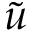Convert formula to latex. <formula><loc_0><loc_0><loc_500><loc_500>\tilde { u }</formula> 